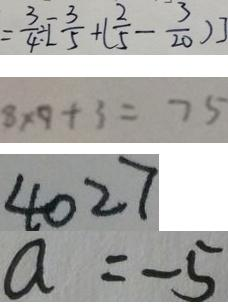Convert formula to latex. <formula><loc_0><loc_0><loc_500><loc_500>= \frac { 3 } { 4 } \div [ \frac { 3 } { 5 } + ( \frac { 2 } { 5 } - \frac { 3 } { 2 0 } ) ] 
 8 \times 9 + 3 = 7 5 
 4 0 2 7 
 a = - 5</formula> 